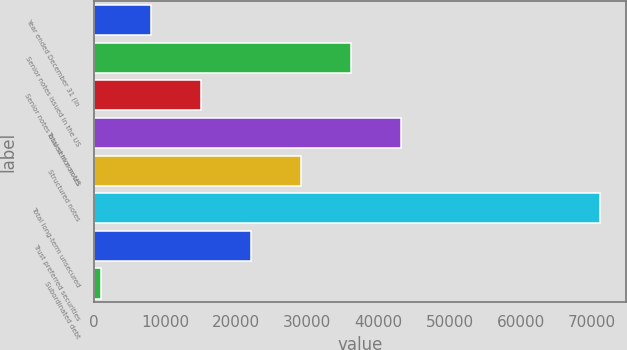Convert chart to OTSL. <chart><loc_0><loc_0><loc_500><loc_500><bar_chart><fcel>Year ended December 31 (in<fcel>Senior notes issued in the US<fcel>Senior notes issued in non-US<fcel>Total senior notes<fcel>Structured notes<fcel>Total long-term unsecured<fcel>Trust preferred securities<fcel>Subordinated debt<nl><fcel>8059.9<fcel>36119.5<fcel>15074.8<fcel>43134.4<fcel>29104.6<fcel>71194<fcel>22089.7<fcel>1045<nl></chart> 